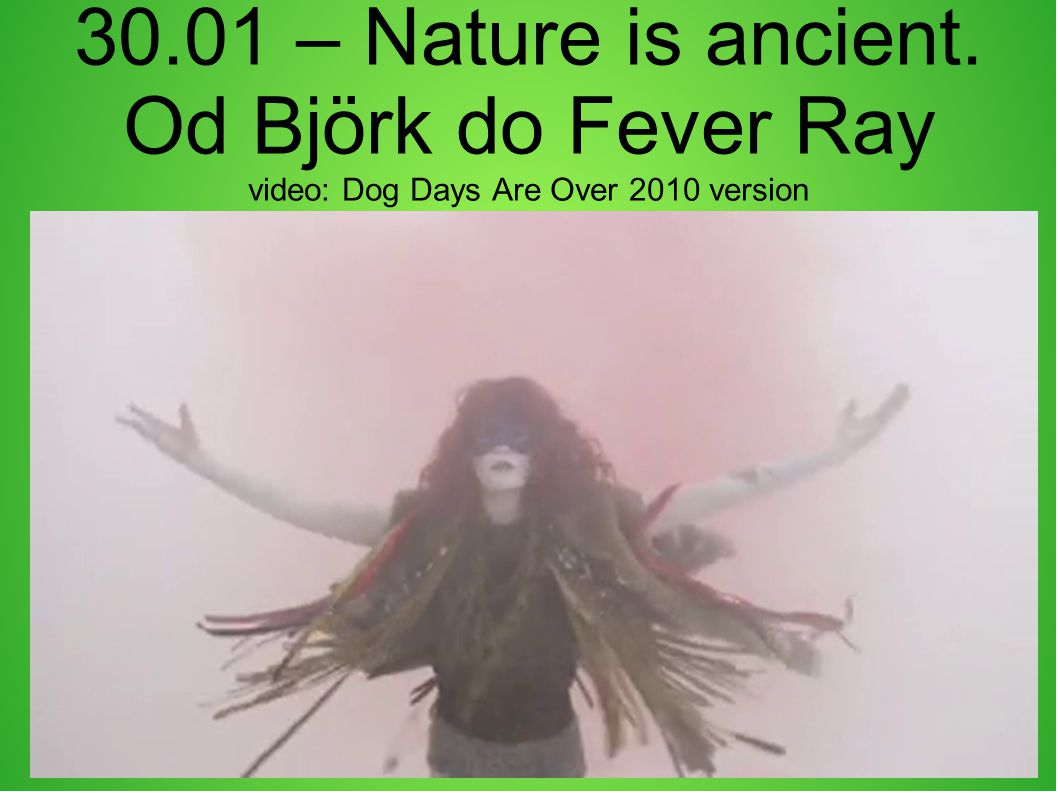What's the first thing that comes to mind when looking at this image? The first thing that comes to mind is the sense of an artistic and dramatic performance. The figure's pose and attire are highly theatrical, suggesting an intense moment captured in time, likely setting the emotional tone for the video. 